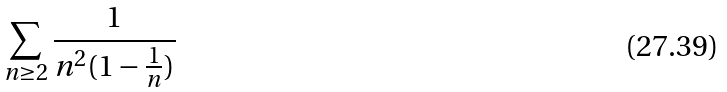Convert formula to latex. <formula><loc_0><loc_0><loc_500><loc_500>\sum _ { n \geq 2 } \frac { 1 } { n ^ { 2 } ( 1 - \frac { 1 } { n } ) }</formula> 